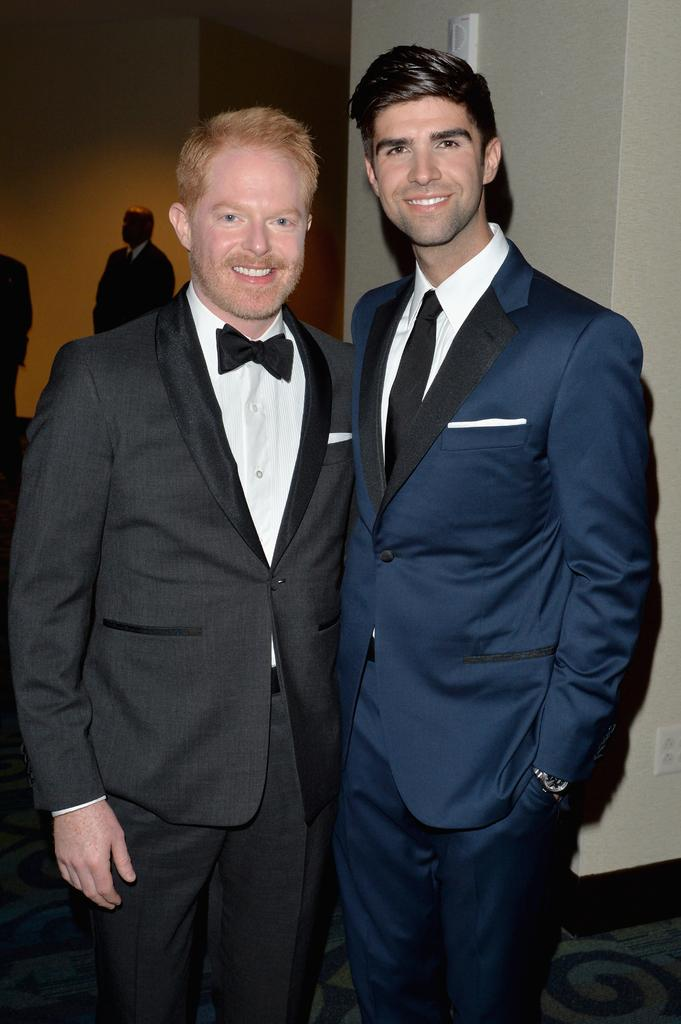How many people can be seen in the image? There are a few people in the image. What can be seen under the people's feet in the image? The ground is visible in the image. What is present on the wall in the image? There is a wall with a few objects in the image. Can you tell me how many birds are sitting on the people's shoulders in the image? There are no birds present in the image; only people, the ground, and objects on the wall can be seen. 